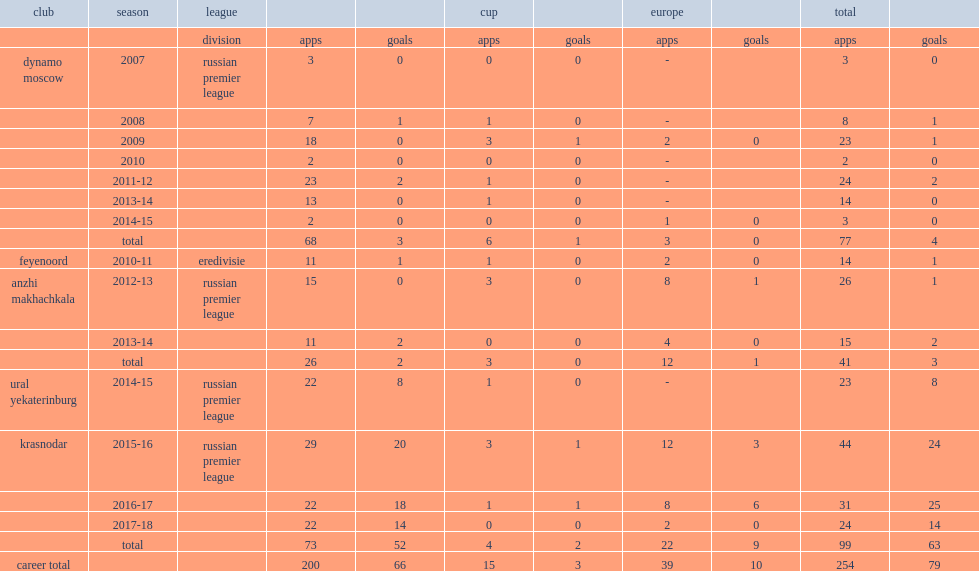How many league goals did fyodor smolov score for krasnodar in 2015-16? 20.0. 